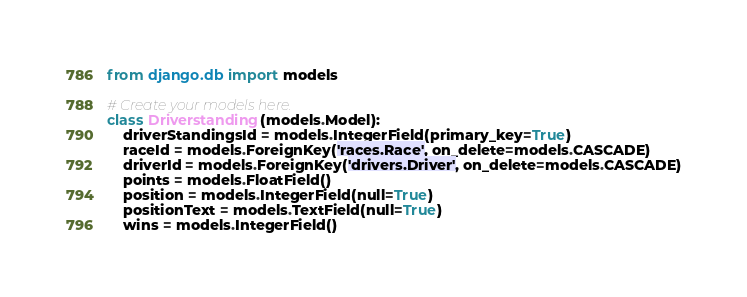<code> <loc_0><loc_0><loc_500><loc_500><_Python_>from django.db import models

# Create your models here.
class Driverstanding(models.Model):
    driverStandingsId = models.IntegerField(primary_key=True)
    raceId = models.ForeignKey('races.Race', on_delete=models.CASCADE)
    driverId = models.ForeignKey('drivers.Driver', on_delete=models.CASCADE)
    points = models.FloatField()
    position = models.IntegerField(null=True)
    positionText = models.TextField(null=True)
    wins = models.IntegerField()</code> 